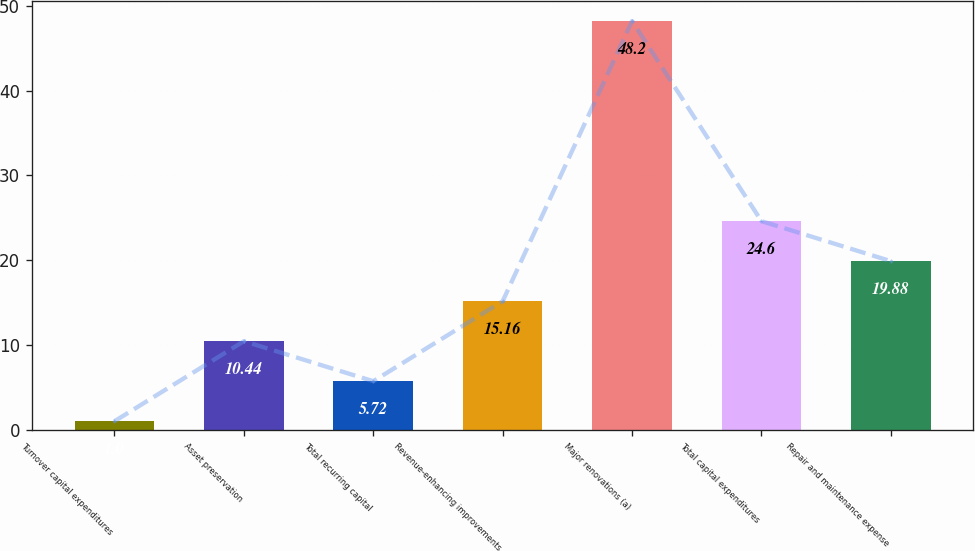Convert chart to OTSL. <chart><loc_0><loc_0><loc_500><loc_500><bar_chart><fcel>Turnover capital expenditures<fcel>Asset preservation<fcel>Total recurring capital<fcel>Revenue-enhancing improvements<fcel>Major renovations (a)<fcel>Total capital expenditures<fcel>Repair and maintenance expense<nl><fcel>1<fcel>10.44<fcel>5.72<fcel>15.16<fcel>48.2<fcel>24.6<fcel>19.88<nl></chart> 